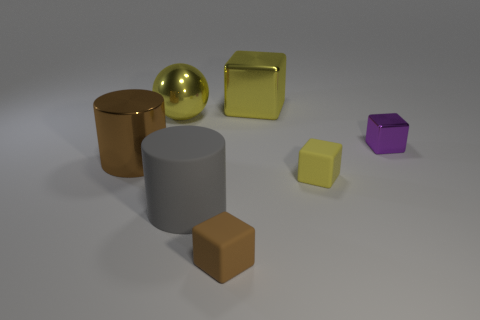Subtract all purple metal blocks. How many blocks are left? 3 Subtract all cylinders. How many objects are left? 5 Subtract 3 cubes. How many cubes are left? 1 Add 3 small red metal balls. How many objects exist? 10 Subtract all yellow cubes. How many cubes are left? 2 Subtract 1 brown cubes. How many objects are left? 6 Subtract all green blocks. Subtract all green cylinders. How many blocks are left? 4 Subtract all brown cubes. How many brown cylinders are left? 1 Subtract all small purple cubes. Subtract all brown metal things. How many objects are left? 5 Add 6 large brown metal cylinders. How many large brown metal cylinders are left? 7 